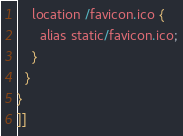<code> <loc_0><loc_0><loc_500><loc_500><_MoonScript_>
    location /favicon.ico {
      alias static/favicon.ico;
    }
  }
}
]]
</code> 